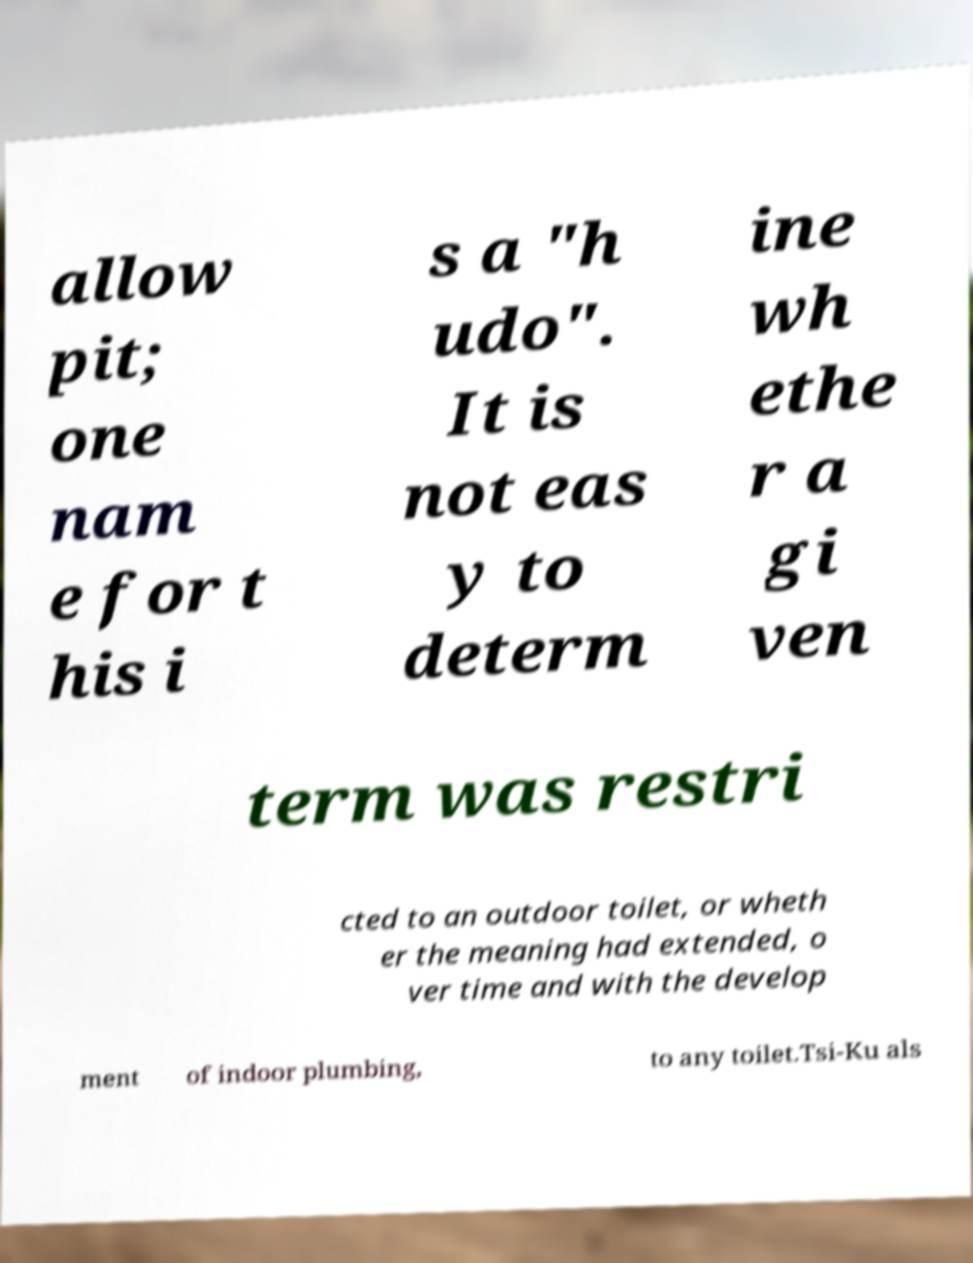Could you assist in decoding the text presented in this image and type it out clearly? allow pit; one nam e for t his i s a "h udo". It is not eas y to determ ine wh ethe r a gi ven term was restri cted to an outdoor toilet, or wheth er the meaning had extended, o ver time and with the develop ment of indoor plumbing, to any toilet.Tsi-Ku als 